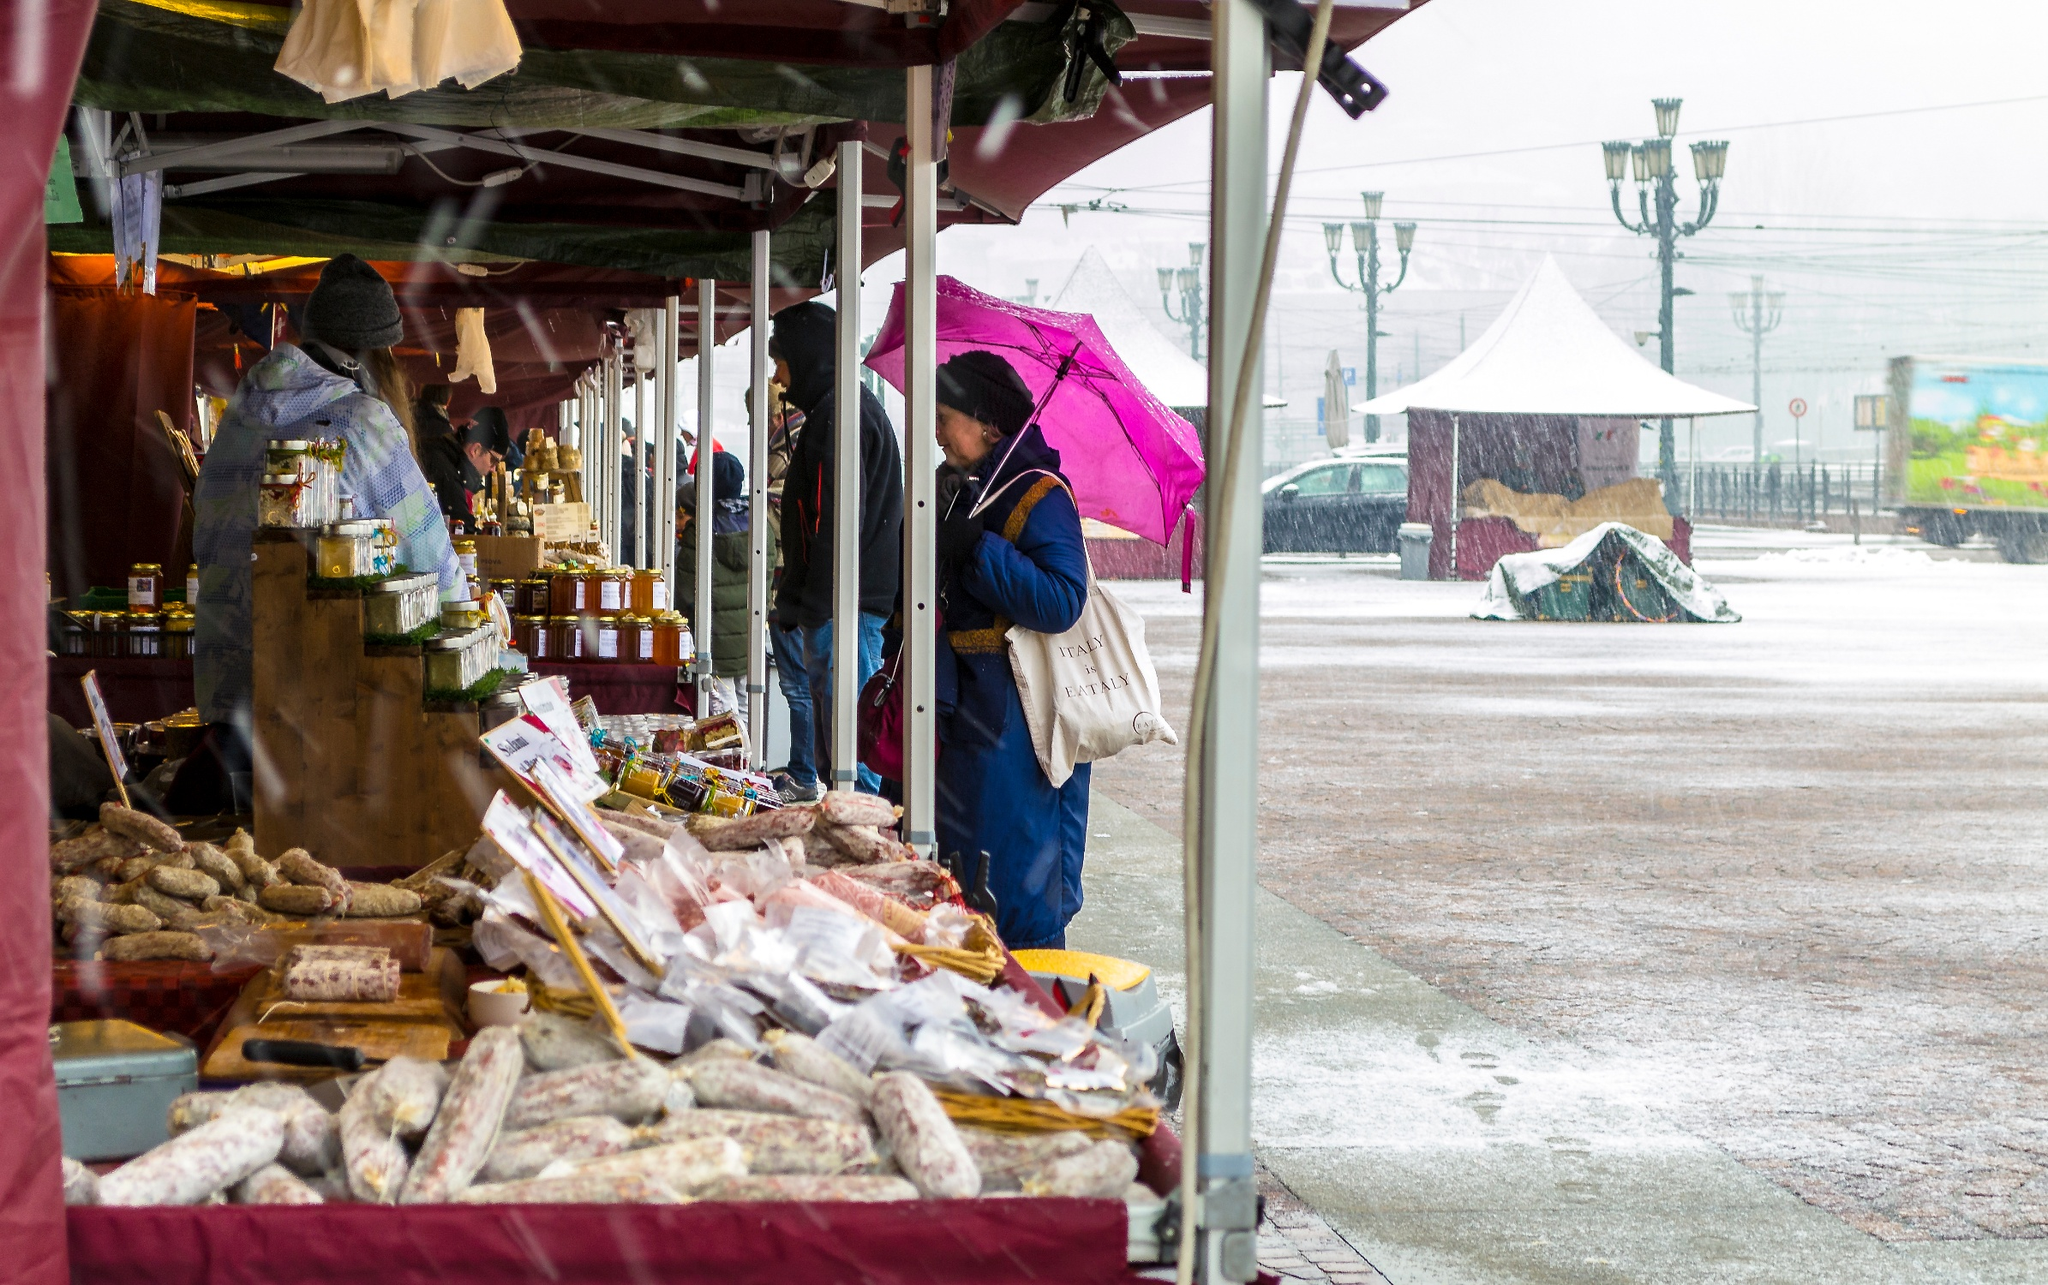What items are being sold at this market stall? The market stall is brimming with various food items. Among the offerings, you can see different types of bread, an assortment of sausages, and numerous jars of preserves such as jams and possibly pickled goods. The items are neatly presented on a wooden counter under a maroon canopy, creating an inviting display for potential customers. It looks like it's raining. How might the weather affect the market activity? Indeed, the rainy weather might have a significant impact on market activity. On one hand, it could deter some customers from venturing out, causing a potential decline in foot traffic. On the other hand, those who do come to the market might be more inclined to make purchases quickly to escape the rain, leading to brisk business for the vendors. The canopies provide necessary shelter, allowing the market to continue operating despite the rain, and might even create a cozy, communal atmosphere among those who brave the adverse weather. Imagine if this market was taking place in the early 1900s. How would it be different? If this market scene were occurring in the early 1900s, there would likely be several noticeable differences. For one, the market stalls might be more rudimentary, perhaps featuring simple wooden structures instead of modern canopies. The clothing of the vendors and customers would be different, likely comprising long coats, hats, and possibly more formal attire typical of that era. The food offerings might also differ slightly, reflecting the period's culinary preferences and preservation methods. Additionally, transportation methods seen in the background would be non-existent or replaced with horse-drawn carriages, adding to the historical ambiance. 